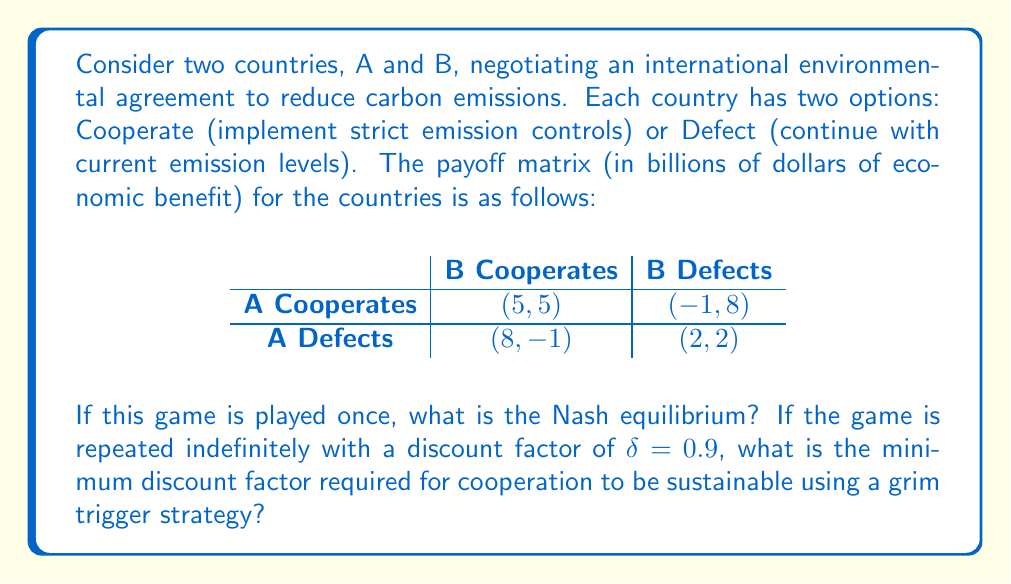What is the answer to this math problem? To solve this problem, we'll follow these steps:

1. Identify the Nash equilibrium for the one-shot game.
2. Calculate the minimum discount factor for cooperation in the repeated game.

Step 1: Nash equilibrium for the one-shot game

In a Prisoner's Dilemma, the dominant strategy for both players is to defect. We can verify this:

For Country A:
- If B cooperates: Defect (8) > Cooperate (5)
- If B defects: Defect (2) > Cooperate (-1)

For Country B:
- If A cooperates: Defect (8) > Cooperate (5)
- If A defects: Defect (2) > Cooperate (-1)

Therefore, the Nash equilibrium is (Defect, Defect) with payoffs (2, 2).

Step 2: Minimum discount factor for cooperation in the repeated game

For cooperation to be sustainable using a grim trigger strategy, the present value of cooperation must be greater than the present value of defection followed by mutual defection forever.

Present value of cooperation:
$$PV_{coop} = 5 + 5\delta + 5\delta^2 + ... = \frac{5}{1-\delta}$$

Present value of defection:
$$PV_{defect} = 8 + 2\delta + 2\delta^2 + ... = 8 + \frac{2\delta}{1-\delta}$$

For cooperation to be sustainable:

$$\frac{5}{1-\delta} \geq 8 + \frac{2\delta}{1-\delta}$$

Solving this inequality:

$$5 \geq 8(1-\delta) + 2\delta$$
$$5 \geq 8 - 8\delta + 2\delta$$
$$5 \geq 8 - 6\delta$$
$$6\delta \geq 3$$
$$\delta \geq \frac{1}{2}$$

Therefore, the minimum discount factor required for cooperation to be sustainable is 0.5.
Answer: The Nash equilibrium for the one-shot game is (Defect, Defect) with payoffs (2, 2). The minimum discount factor required for cooperation to be sustainable in the indefinitely repeated game using a grim trigger strategy is $\delta = 0.5$. 